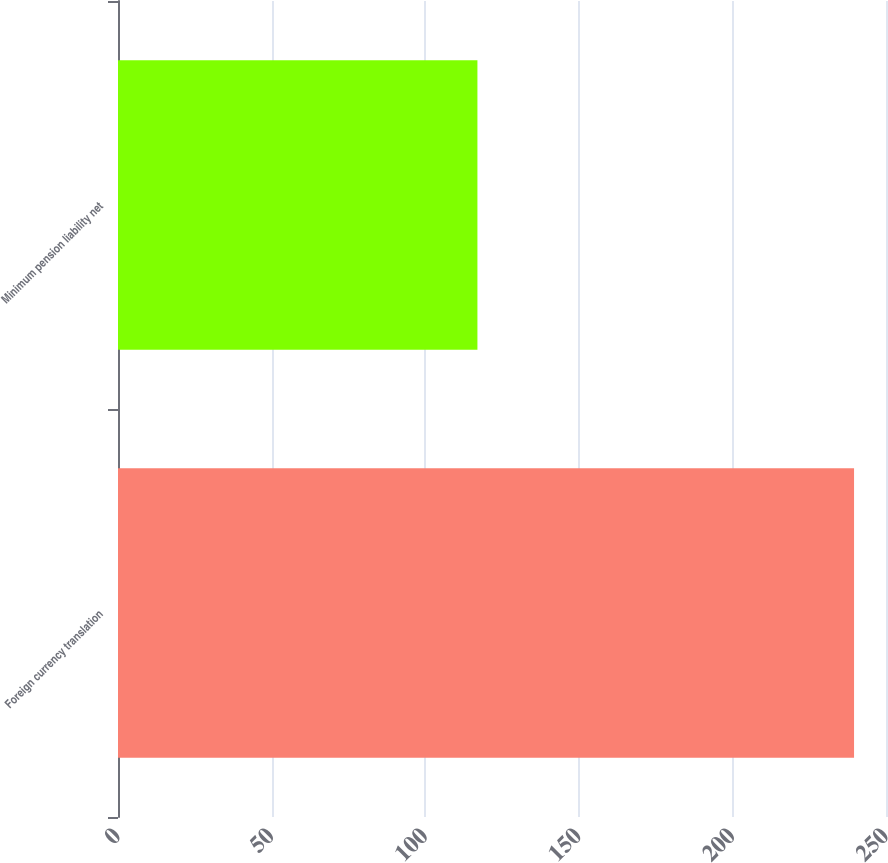<chart> <loc_0><loc_0><loc_500><loc_500><bar_chart><fcel>Foreign currency translation<fcel>Minimum pension liability net<nl><fcel>239.6<fcel>117<nl></chart> 